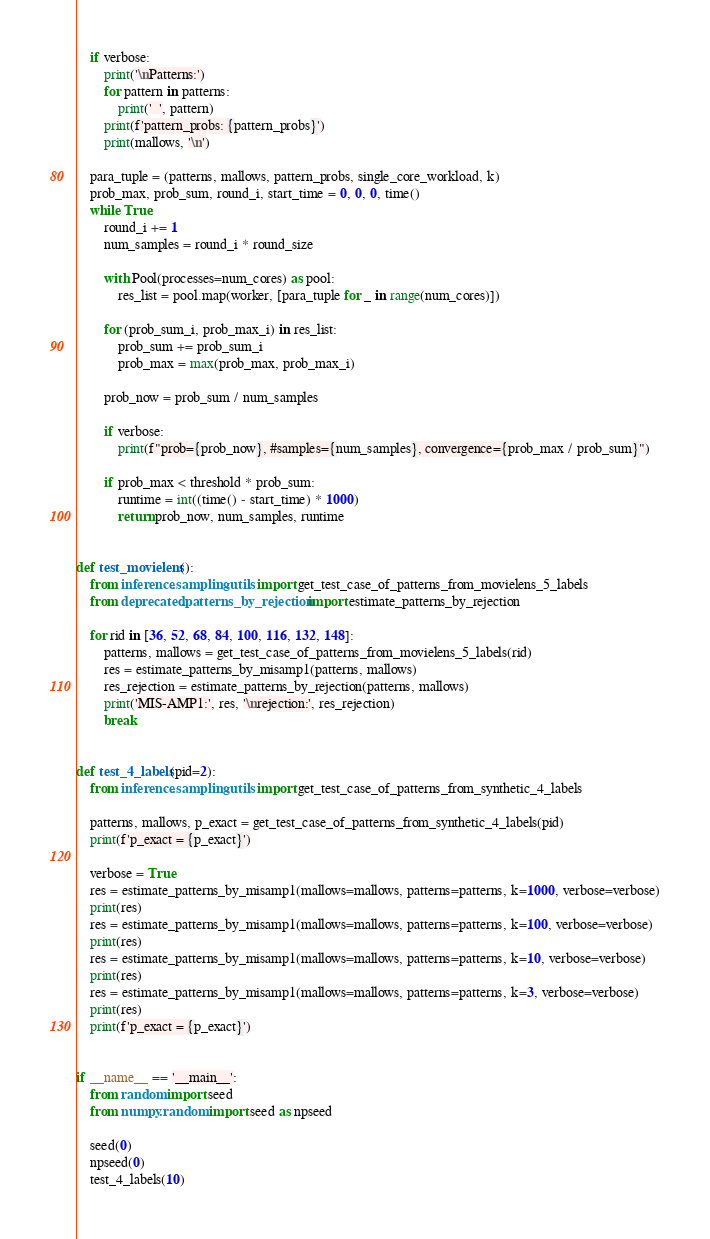<code> <loc_0><loc_0><loc_500><loc_500><_Python_>
    if verbose:
        print('\nPatterns:')
        for pattern in patterns:
            print('  ', pattern)
        print(f'pattern_probs: {pattern_probs}')
        print(mallows, '\n')

    para_tuple = (patterns, mallows, pattern_probs, single_core_workload, k)
    prob_max, prob_sum, round_i, start_time = 0, 0, 0, time()
    while True:
        round_i += 1
        num_samples = round_i * round_size

        with Pool(processes=num_cores) as pool:
            res_list = pool.map(worker, [para_tuple for _ in range(num_cores)])

        for (prob_sum_i, prob_max_i) in res_list:
            prob_sum += prob_sum_i
            prob_max = max(prob_max, prob_max_i)

        prob_now = prob_sum / num_samples

        if verbose:
            print(f"prob={prob_now}, #samples={num_samples}, convergence={prob_max / prob_sum}")

        if prob_max < threshold * prob_sum:
            runtime = int((time() - start_time) * 1000)
            return prob_now, num_samples, runtime


def test_movielens():
    from inference.sampling.utils import get_test_case_of_patterns_from_movielens_5_labels
    from deprecated.patterns_by_rejection import estimate_patterns_by_rejection

    for rid in [36, 52, 68, 84, 100, 116, 132, 148]:
        patterns, mallows = get_test_case_of_patterns_from_movielens_5_labels(rid)
        res = estimate_patterns_by_misamp1(patterns, mallows)
        res_rejection = estimate_patterns_by_rejection(patterns, mallows)
        print('MIS-AMP1:', res, '\nrejection:', res_rejection)
        break


def test_4_labels(pid=2):
    from inference.sampling.utils import get_test_case_of_patterns_from_synthetic_4_labels

    patterns, mallows, p_exact = get_test_case_of_patterns_from_synthetic_4_labels(pid)
    print(f'p_exact = {p_exact}')

    verbose = True
    res = estimate_patterns_by_misamp1(mallows=mallows, patterns=patterns, k=1000, verbose=verbose)
    print(res)
    res = estimate_patterns_by_misamp1(mallows=mallows, patterns=patterns, k=100, verbose=verbose)
    print(res)
    res = estimate_patterns_by_misamp1(mallows=mallows, patterns=patterns, k=10, verbose=verbose)
    print(res)
    res = estimate_patterns_by_misamp1(mallows=mallows, patterns=patterns, k=3, verbose=verbose)
    print(res)
    print(f'p_exact = {p_exact}')


if __name__ == '__main__':
    from random import seed
    from numpy.random import seed as npseed

    seed(0)
    npseed(0)
    test_4_labels(10)
</code> 